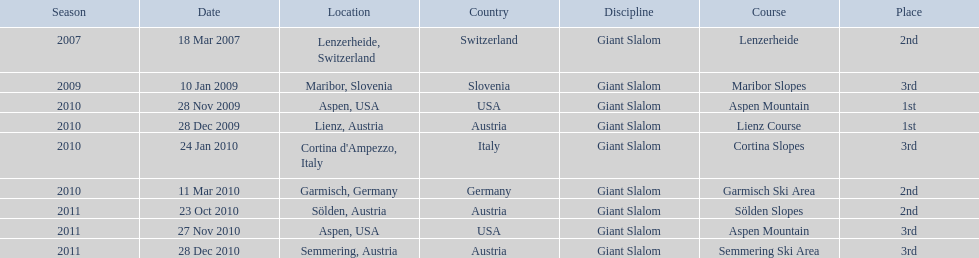What was the finishing place of the last race in december 2010? 3rd. 